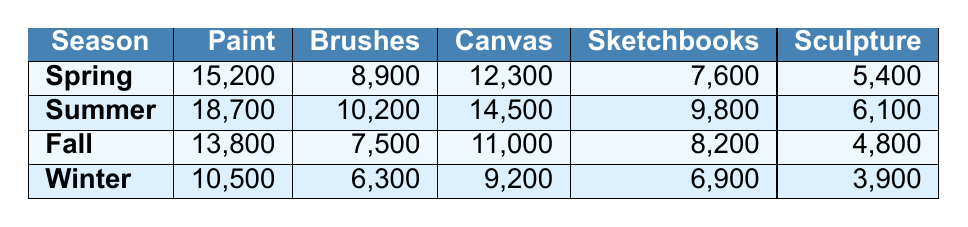What is the total sales of Paint in Summer? From the table, the sales of Paint in Summer is directly listed as 18,700.
Answer: 18,700 Which season has the highest sales for Sketchbooks? Looking at the row for Sketchbooks, the highest sales value is 9,800 in Summer.
Answer: Summer What is the difference in sales of Brushes between Spring and Winter? For Brushes, Spring sales are 8,900 and Winter sales are 6,300. The difference is 8,900 - 6,300 = 2,600.
Answer: 2,600 How much did Sculpture Materials sell in Fall? The sales for Sculpture Materials in Fall is directly listed as 4,800.
Answer: 4,800 What is the average sales of Canvas across all seasons? The sales values for Canvas are: Spring (12,300), Summer (14,500), Fall (11,000), and Winter (9,200). Summing these gives 12,300 + 14,500 + 11,000 + 9,200 = 47,000. There are 4 seasons, so the average is 47,000 / 4 = 11,750.
Answer: 11,750 Did Winter have higher sales of Paint than Fall? In the table, Paint sales are 10,500 in Winter and 13,800 in Fall. Since 10,500 is less than 13,800, the statement is false.
Answer: No Which product category had the lowest sales in Spring? Reviewing the Spring data, the sales figures are Paint (15,200), Brushes (8,900), Canvas (12,300), Sketchbooks (7,600), and Sculpture Materials (5,400). The lowest value here is for Sculpture Materials with 5,400.
Answer: Sculpture Materials What is the total sales for all categories in Summer? Summing the sales in Summer: Paint (18,700) + Brushes (10,200) + Canvas (14,500) + Sketchbooks (9,800) + Sculpture Materials (6,100) equals 18,700 + 10,200 + 14,500 + 9,800 + 6,100 = 69,300.
Answer: 69,300 In which season do Brush sales exceed 9,000? Checking the sales values: Spring (8,900), Summer (10,200), Fall (7,500), and Winter (6,300). Brush sales exceed 9,000 only in Summer.
Answer: Summer Which category showed the greatest decrease in sales from Spring to Winter? For each category, we compare sales: Paint drops from 15,200 to 10,500 (4,700), Brushes drop from 8,900 to 6,300 (2,600), Canvas drops from 12,300 to 9,200 (3,100), Sketchbooks drop from 7,600 to 6,900 (700), and Sculpture Materials drop from 5,400 to 3,900 (1,500). The greatest decrease is in Paint.
Answer: Paint 